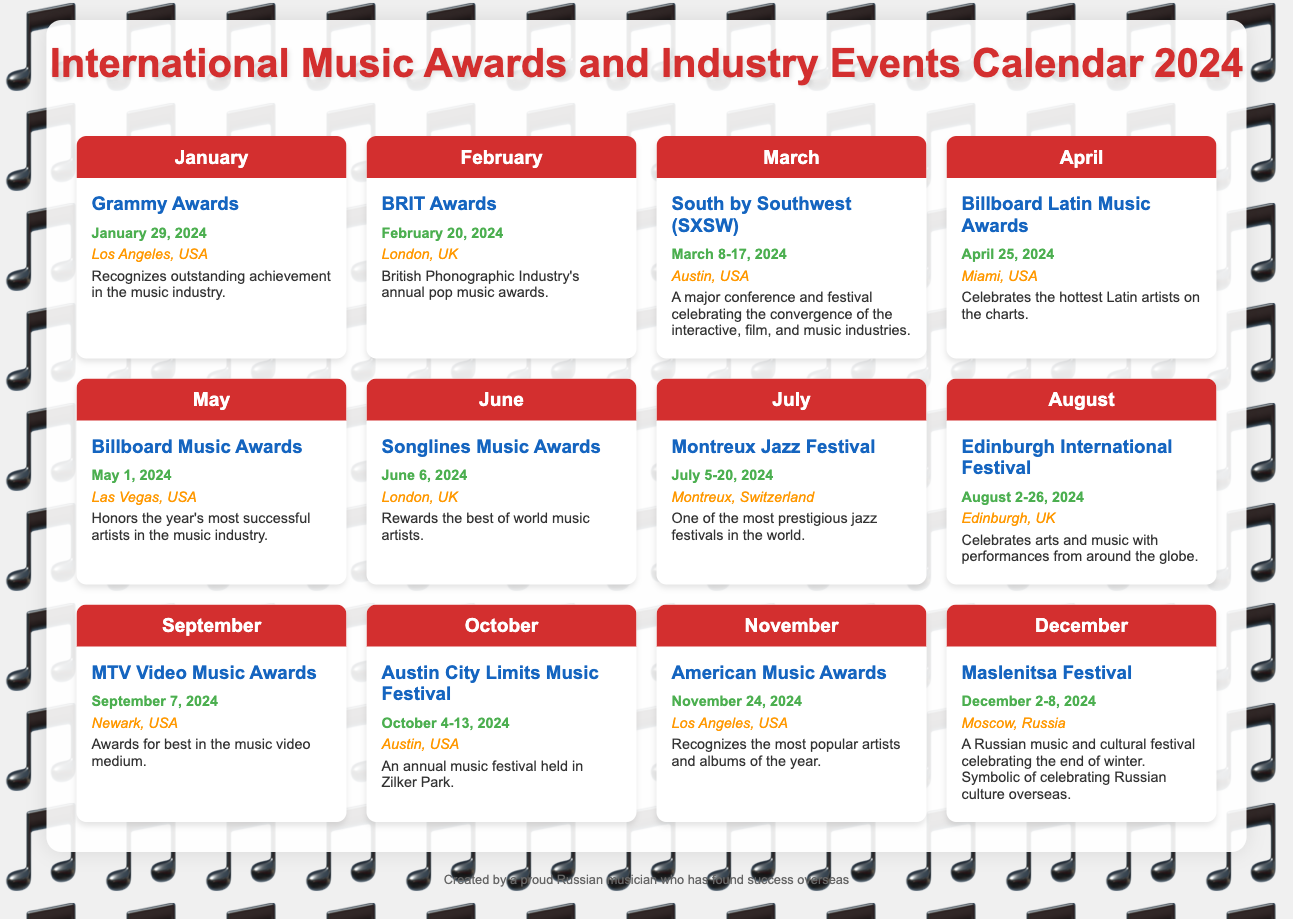What event takes place on January 29, 2024? The document lists the Grammy Awards as the event for that date.
Answer: Grammy Awards Where is the BRIT Awards held? The location of the BRIT Awards is specified in the document as London, UK.
Answer: London, UK How many days does the South by Southwest (SXSW) festival last? The document mentions that it takes place from March 8 to March 17, which is a span of 10 days.
Answer: 10 days Which event celebrates Latin artists? Billboard Latin Music Awards are the ones that celebrate Latin artists according to the document.
Answer: Billboard Latin Music Awards What month hosts the MTV Video Music Awards? The document states that the MTV Video Music Awards occurs in September.
Answer: September Which two events occur in August? The document lists the Edinburgh International Festival as the event in August along with its dates.
Answer: Edinburgh International Festival What is the date range for the Maslenitsa Festival? The date range provided for the Maslenitsa Festival is December 2-8, 2024.
Answer: December 2-8, 2024 How does the document describe the significance of the Maslenitsa Festival? The document describes it as celebrating Russian culture overseas.
Answer: Celebrating Russian culture overseas What types of music does the Songlines Music Awards recognize? The awards recognize the best of world music artists.
Answer: World music artists 